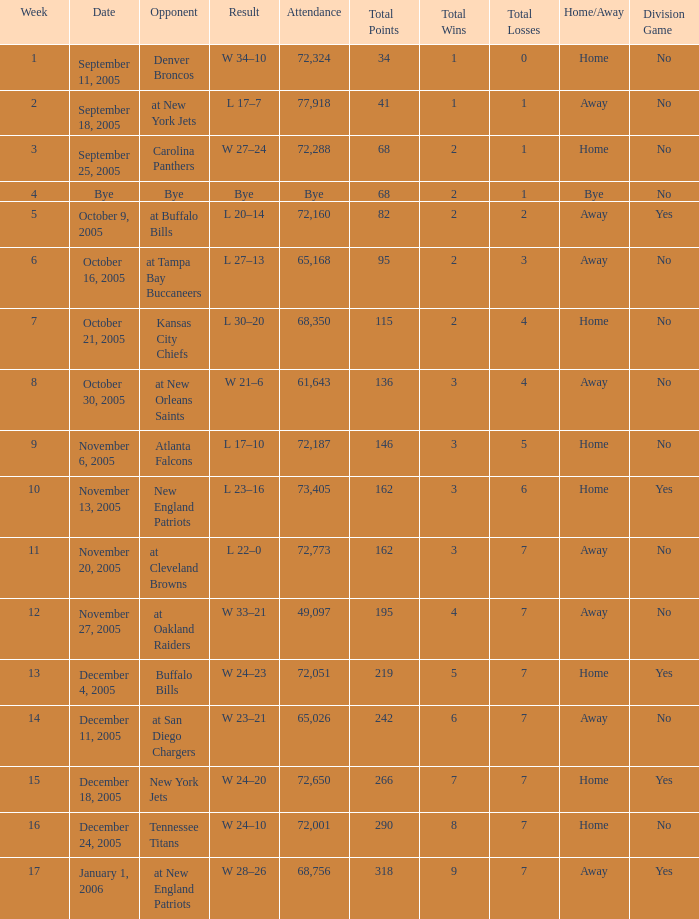What is the Date of the game with an attendance of 72,051 after Week 9? December 4, 2005. 